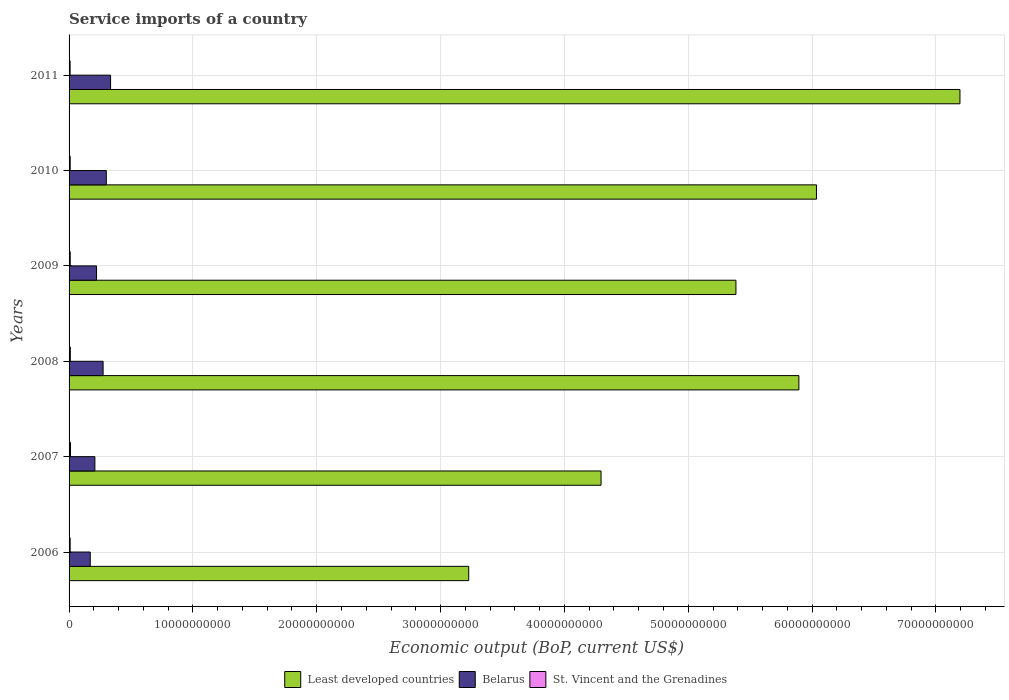How many different coloured bars are there?
Offer a very short reply. 3. How many groups of bars are there?
Give a very brief answer. 6. Are the number of bars on each tick of the Y-axis equal?
Give a very brief answer. Yes. How many bars are there on the 4th tick from the top?
Your answer should be compact. 3. How many bars are there on the 5th tick from the bottom?
Give a very brief answer. 3. What is the label of the 1st group of bars from the top?
Make the answer very short. 2011. What is the service imports in St. Vincent and the Grenadines in 2008?
Offer a very short reply. 1.02e+08. Across all years, what is the maximum service imports in Belarus?
Ensure brevity in your answer.  3.35e+09. Across all years, what is the minimum service imports in St. Vincent and the Grenadines?
Provide a succinct answer. 8.43e+07. In which year was the service imports in St. Vincent and the Grenadines minimum?
Give a very brief answer. 2011. What is the total service imports in St. Vincent and the Grenadines in the graph?
Your answer should be very brief. 5.75e+08. What is the difference between the service imports in Least developed countries in 2009 and that in 2011?
Your response must be concise. -1.81e+1. What is the difference between the service imports in Least developed countries in 2010 and the service imports in St. Vincent and the Grenadines in 2007?
Ensure brevity in your answer.  6.02e+1. What is the average service imports in Least developed countries per year?
Provide a succinct answer. 5.34e+1. In the year 2006, what is the difference between the service imports in St. Vincent and the Grenadines and service imports in Least developed countries?
Ensure brevity in your answer.  -3.22e+1. In how many years, is the service imports in Least developed countries greater than 50000000000 US$?
Provide a short and direct response. 4. What is the ratio of the service imports in St. Vincent and the Grenadines in 2006 to that in 2010?
Provide a succinct answer. 0.96. Is the service imports in Least developed countries in 2009 less than that in 2010?
Give a very brief answer. Yes. What is the difference between the highest and the second highest service imports in St. Vincent and the Grenadines?
Provide a succinct answer. 1.21e+07. What is the difference between the highest and the lowest service imports in St. Vincent and the Grenadines?
Give a very brief answer. 2.99e+07. In how many years, is the service imports in Belarus greater than the average service imports in Belarus taken over all years?
Your response must be concise. 3. What does the 3rd bar from the top in 2008 represents?
Offer a very short reply. Least developed countries. What does the 1st bar from the bottom in 2011 represents?
Make the answer very short. Least developed countries. How many bars are there?
Offer a terse response. 18. What is the difference between two consecutive major ticks on the X-axis?
Offer a very short reply. 1.00e+1. Are the values on the major ticks of X-axis written in scientific E-notation?
Your answer should be very brief. No. Does the graph contain any zero values?
Provide a succinct answer. No. Does the graph contain grids?
Offer a terse response. Yes. Where does the legend appear in the graph?
Offer a very short reply. Bottom center. How many legend labels are there?
Make the answer very short. 3. What is the title of the graph?
Provide a succinct answer. Service imports of a country. What is the label or title of the X-axis?
Make the answer very short. Economic output (BoP, current US$). What is the Economic output (BoP, current US$) of Least developed countries in 2006?
Offer a very short reply. 3.23e+1. What is the Economic output (BoP, current US$) in Belarus in 2006?
Make the answer very short. 1.71e+09. What is the Economic output (BoP, current US$) in St. Vincent and the Grenadines in 2006?
Your answer should be very brief. 8.82e+07. What is the Economic output (BoP, current US$) of Least developed countries in 2007?
Your response must be concise. 4.30e+1. What is the Economic output (BoP, current US$) of Belarus in 2007?
Your response must be concise. 2.08e+09. What is the Economic output (BoP, current US$) in St. Vincent and the Grenadines in 2007?
Make the answer very short. 1.14e+08. What is the Economic output (BoP, current US$) in Least developed countries in 2008?
Offer a very short reply. 5.89e+1. What is the Economic output (BoP, current US$) of Belarus in 2008?
Offer a very short reply. 2.75e+09. What is the Economic output (BoP, current US$) in St. Vincent and the Grenadines in 2008?
Keep it short and to the point. 1.02e+08. What is the Economic output (BoP, current US$) in Least developed countries in 2009?
Give a very brief answer. 5.39e+1. What is the Economic output (BoP, current US$) in Belarus in 2009?
Ensure brevity in your answer.  2.22e+09. What is the Economic output (BoP, current US$) of St. Vincent and the Grenadines in 2009?
Your answer should be very brief. 9.42e+07. What is the Economic output (BoP, current US$) of Least developed countries in 2010?
Offer a very short reply. 6.04e+1. What is the Economic output (BoP, current US$) of Belarus in 2010?
Your answer should be very brief. 3.01e+09. What is the Economic output (BoP, current US$) of St. Vincent and the Grenadines in 2010?
Offer a terse response. 9.15e+07. What is the Economic output (BoP, current US$) in Least developed countries in 2011?
Ensure brevity in your answer.  7.19e+1. What is the Economic output (BoP, current US$) of Belarus in 2011?
Provide a succinct answer. 3.35e+09. What is the Economic output (BoP, current US$) of St. Vincent and the Grenadines in 2011?
Offer a very short reply. 8.43e+07. Across all years, what is the maximum Economic output (BoP, current US$) of Least developed countries?
Your answer should be compact. 7.19e+1. Across all years, what is the maximum Economic output (BoP, current US$) in Belarus?
Your response must be concise. 3.35e+09. Across all years, what is the maximum Economic output (BoP, current US$) of St. Vincent and the Grenadines?
Make the answer very short. 1.14e+08. Across all years, what is the minimum Economic output (BoP, current US$) in Least developed countries?
Offer a very short reply. 3.23e+1. Across all years, what is the minimum Economic output (BoP, current US$) of Belarus?
Provide a short and direct response. 1.71e+09. Across all years, what is the minimum Economic output (BoP, current US$) in St. Vincent and the Grenadines?
Your response must be concise. 8.43e+07. What is the total Economic output (BoP, current US$) of Least developed countries in the graph?
Your answer should be compact. 3.20e+11. What is the total Economic output (BoP, current US$) in Belarus in the graph?
Ensure brevity in your answer.  1.51e+1. What is the total Economic output (BoP, current US$) of St. Vincent and the Grenadines in the graph?
Ensure brevity in your answer.  5.75e+08. What is the difference between the Economic output (BoP, current US$) in Least developed countries in 2006 and that in 2007?
Give a very brief answer. -1.07e+1. What is the difference between the Economic output (BoP, current US$) of Belarus in 2006 and that in 2007?
Provide a short and direct response. -3.74e+08. What is the difference between the Economic output (BoP, current US$) in St. Vincent and the Grenadines in 2006 and that in 2007?
Keep it short and to the point. -2.60e+07. What is the difference between the Economic output (BoP, current US$) in Least developed countries in 2006 and that in 2008?
Ensure brevity in your answer.  -2.67e+1. What is the difference between the Economic output (BoP, current US$) in Belarus in 2006 and that in 2008?
Your answer should be very brief. -1.04e+09. What is the difference between the Economic output (BoP, current US$) of St. Vincent and the Grenadines in 2006 and that in 2008?
Your response must be concise. -1.40e+07. What is the difference between the Economic output (BoP, current US$) in Least developed countries in 2006 and that in 2009?
Your response must be concise. -2.16e+1. What is the difference between the Economic output (BoP, current US$) in Belarus in 2006 and that in 2009?
Your response must be concise. -5.07e+08. What is the difference between the Economic output (BoP, current US$) of St. Vincent and the Grenadines in 2006 and that in 2009?
Provide a short and direct response. -6.06e+06. What is the difference between the Economic output (BoP, current US$) in Least developed countries in 2006 and that in 2010?
Give a very brief answer. -2.81e+1. What is the difference between the Economic output (BoP, current US$) in Belarus in 2006 and that in 2010?
Provide a short and direct response. -1.30e+09. What is the difference between the Economic output (BoP, current US$) in St. Vincent and the Grenadines in 2006 and that in 2010?
Provide a short and direct response. -3.29e+06. What is the difference between the Economic output (BoP, current US$) of Least developed countries in 2006 and that in 2011?
Offer a terse response. -3.97e+1. What is the difference between the Economic output (BoP, current US$) of Belarus in 2006 and that in 2011?
Offer a terse response. -1.64e+09. What is the difference between the Economic output (BoP, current US$) of St. Vincent and the Grenadines in 2006 and that in 2011?
Provide a succinct answer. 3.84e+06. What is the difference between the Economic output (BoP, current US$) of Least developed countries in 2007 and that in 2008?
Give a very brief answer. -1.60e+1. What is the difference between the Economic output (BoP, current US$) in Belarus in 2007 and that in 2008?
Your response must be concise. -6.63e+08. What is the difference between the Economic output (BoP, current US$) in St. Vincent and the Grenadines in 2007 and that in 2008?
Ensure brevity in your answer.  1.21e+07. What is the difference between the Economic output (BoP, current US$) in Least developed countries in 2007 and that in 2009?
Provide a short and direct response. -1.09e+1. What is the difference between the Economic output (BoP, current US$) in Belarus in 2007 and that in 2009?
Offer a terse response. -1.33e+08. What is the difference between the Economic output (BoP, current US$) in St. Vincent and the Grenadines in 2007 and that in 2009?
Offer a terse response. 2.00e+07. What is the difference between the Economic output (BoP, current US$) in Least developed countries in 2007 and that in 2010?
Your response must be concise. -1.74e+1. What is the difference between the Economic output (BoP, current US$) in Belarus in 2007 and that in 2010?
Provide a short and direct response. -9.22e+08. What is the difference between the Economic output (BoP, current US$) in St. Vincent and the Grenadines in 2007 and that in 2010?
Keep it short and to the point. 2.27e+07. What is the difference between the Economic output (BoP, current US$) of Least developed countries in 2007 and that in 2011?
Keep it short and to the point. -2.90e+1. What is the difference between the Economic output (BoP, current US$) of Belarus in 2007 and that in 2011?
Your response must be concise. -1.27e+09. What is the difference between the Economic output (BoP, current US$) of St. Vincent and the Grenadines in 2007 and that in 2011?
Make the answer very short. 2.99e+07. What is the difference between the Economic output (BoP, current US$) of Least developed countries in 2008 and that in 2009?
Provide a succinct answer. 5.08e+09. What is the difference between the Economic output (BoP, current US$) of Belarus in 2008 and that in 2009?
Provide a short and direct response. 5.30e+08. What is the difference between the Economic output (BoP, current US$) in St. Vincent and the Grenadines in 2008 and that in 2009?
Keep it short and to the point. 7.90e+06. What is the difference between the Economic output (BoP, current US$) in Least developed countries in 2008 and that in 2010?
Give a very brief answer. -1.42e+09. What is the difference between the Economic output (BoP, current US$) in Belarus in 2008 and that in 2010?
Your answer should be very brief. -2.59e+08. What is the difference between the Economic output (BoP, current US$) of St. Vincent and the Grenadines in 2008 and that in 2010?
Your answer should be compact. 1.07e+07. What is the difference between the Economic output (BoP, current US$) in Least developed countries in 2008 and that in 2011?
Your answer should be very brief. -1.30e+1. What is the difference between the Economic output (BoP, current US$) of Belarus in 2008 and that in 2011?
Offer a terse response. -6.04e+08. What is the difference between the Economic output (BoP, current US$) of St. Vincent and the Grenadines in 2008 and that in 2011?
Keep it short and to the point. 1.78e+07. What is the difference between the Economic output (BoP, current US$) in Least developed countries in 2009 and that in 2010?
Make the answer very short. -6.50e+09. What is the difference between the Economic output (BoP, current US$) of Belarus in 2009 and that in 2010?
Your answer should be compact. -7.89e+08. What is the difference between the Economic output (BoP, current US$) in St. Vincent and the Grenadines in 2009 and that in 2010?
Your answer should be very brief. 2.78e+06. What is the difference between the Economic output (BoP, current US$) in Least developed countries in 2009 and that in 2011?
Offer a terse response. -1.81e+1. What is the difference between the Economic output (BoP, current US$) in Belarus in 2009 and that in 2011?
Keep it short and to the point. -1.13e+09. What is the difference between the Economic output (BoP, current US$) of St. Vincent and the Grenadines in 2009 and that in 2011?
Provide a short and direct response. 9.90e+06. What is the difference between the Economic output (BoP, current US$) in Least developed countries in 2010 and that in 2011?
Ensure brevity in your answer.  -1.16e+1. What is the difference between the Economic output (BoP, current US$) in Belarus in 2010 and that in 2011?
Offer a very short reply. -3.45e+08. What is the difference between the Economic output (BoP, current US$) of St. Vincent and the Grenadines in 2010 and that in 2011?
Ensure brevity in your answer.  7.13e+06. What is the difference between the Economic output (BoP, current US$) of Least developed countries in 2006 and the Economic output (BoP, current US$) of Belarus in 2007?
Offer a terse response. 3.02e+1. What is the difference between the Economic output (BoP, current US$) of Least developed countries in 2006 and the Economic output (BoP, current US$) of St. Vincent and the Grenadines in 2007?
Provide a succinct answer. 3.22e+1. What is the difference between the Economic output (BoP, current US$) of Belarus in 2006 and the Economic output (BoP, current US$) of St. Vincent and the Grenadines in 2007?
Offer a very short reply. 1.60e+09. What is the difference between the Economic output (BoP, current US$) in Least developed countries in 2006 and the Economic output (BoP, current US$) in Belarus in 2008?
Keep it short and to the point. 2.95e+1. What is the difference between the Economic output (BoP, current US$) of Least developed countries in 2006 and the Economic output (BoP, current US$) of St. Vincent and the Grenadines in 2008?
Give a very brief answer. 3.22e+1. What is the difference between the Economic output (BoP, current US$) of Belarus in 2006 and the Economic output (BoP, current US$) of St. Vincent and the Grenadines in 2008?
Provide a succinct answer. 1.61e+09. What is the difference between the Economic output (BoP, current US$) in Least developed countries in 2006 and the Economic output (BoP, current US$) in Belarus in 2009?
Offer a terse response. 3.01e+1. What is the difference between the Economic output (BoP, current US$) of Least developed countries in 2006 and the Economic output (BoP, current US$) of St. Vincent and the Grenadines in 2009?
Your answer should be very brief. 3.22e+1. What is the difference between the Economic output (BoP, current US$) of Belarus in 2006 and the Economic output (BoP, current US$) of St. Vincent and the Grenadines in 2009?
Offer a terse response. 1.62e+09. What is the difference between the Economic output (BoP, current US$) in Least developed countries in 2006 and the Economic output (BoP, current US$) in Belarus in 2010?
Make the answer very short. 2.93e+1. What is the difference between the Economic output (BoP, current US$) of Least developed countries in 2006 and the Economic output (BoP, current US$) of St. Vincent and the Grenadines in 2010?
Ensure brevity in your answer.  3.22e+1. What is the difference between the Economic output (BoP, current US$) in Belarus in 2006 and the Economic output (BoP, current US$) in St. Vincent and the Grenadines in 2010?
Your answer should be very brief. 1.62e+09. What is the difference between the Economic output (BoP, current US$) of Least developed countries in 2006 and the Economic output (BoP, current US$) of Belarus in 2011?
Your response must be concise. 2.89e+1. What is the difference between the Economic output (BoP, current US$) of Least developed countries in 2006 and the Economic output (BoP, current US$) of St. Vincent and the Grenadines in 2011?
Provide a short and direct response. 3.22e+1. What is the difference between the Economic output (BoP, current US$) in Belarus in 2006 and the Economic output (BoP, current US$) in St. Vincent and the Grenadines in 2011?
Offer a terse response. 1.63e+09. What is the difference between the Economic output (BoP, current US$) of Least developed countries in 2007 and the Economic output (BoP, current US$) of Belarus in 2008?
Your answer should be very brief. 4.02e+1. What is the difference between the Economic output (BoP, current US$) of Least developed countries in 2007 and the Economic output (BoP, current US$) of St. Vincent and the Grenadines in 2008?
Provide a succinct answer. 4.29e+1. What is the difference between the Economic output (BoP, current US$) in Belarus in 2007 and the Economic output (BoP, current US$) in St. Vincent and the Grenadines in 2008?
Your answer should be very brief. 1.98e+09. What is the difference between the Economic output (BoP, current US$) of Least developed countries in 2007 and the Economic output (BoP, current US$) of Belarus in 2009?
Provide a short and direct response. 4.07e+1. What is the difference between the Economic output (BoP, current US$) of Least developed countries in 2007 and the Economic output (BoP, current US$) of St. Vincent and the Grenadines in 2009?
Offer a very short reply. 4.29e+1. What is the difference between the Economic output (BoP, current US$) of Belarus in 2007 and the Economic output (BoP, current US$) of St. Vincent and the Grenadines in 2009?
Offer a very short reply. 1.99e+09. What is the difference between the Economic output (BoP, current US$) of Least developed countries in 2007 and the Economic output (BoP, current US$) of Belarus in 2010?
Your answer should be very brief. 4.00e+1. What is the difference between the Economic output (BoP, current US$) in Least developed countries in 2007 and the Economic output (BoP, current US$) in St. Vincent and the Grenadines in 2010?
Make the answer very short. 4.29e+1. What is the difference between the Economic output (BoP, current US$) in Belarus in 2007 and the Economic output (BoP, current US$) in St. Vincent and the Grenadines in 2010?
Make the answer very short. 1.99e+09. What is the difference between the Economic output (BoP, current US$) in Least developed countries in 2007 and the Economic output (BoP, current US$) in Belarus in 2011?
Your answer should be compact. 3.96e+1. What is the difference between the Economic output (BoP, current US$) in Least developed countries in 2007 and the Economic output (BoP, current US$) in St. Vincent and the Grenadines in 2011?
Offer a very short reply. 4.29e+1. What is the difference between the Economic output (BoP, current US$) of Belarus in 2007 and the Economic output (BoP, current US$) of St. Vincent and the Grenadines in 2011?
Offer a terse response. 2.00e+09. What is the difference between the Economic output (BoP, current US$) in Least developed countries in 2008 and the Economic output (BoP, current US$) in Belarus in 2009?
Give a very brief answer. 5.67e+1. What is the difference between the Economic output (BoP, current US$) of Least developed countries in 2008 and the Economic output (BoP, current US$) of St. Vincent and the Grenadines in 2009?
Ensure brevity in your answer.  5.88e+1. What is the difference between the Economic output (BoP, current US$) in Belarus in 2008 and the Economic output (BoP, current US$) in St. Vincent and the Grenadines in 2009?
Provide a short and direct response. 2.65e+09. What is the difference between the Economic output (BoP, current US$) of Least developed countries in 2008 and the Economic output (BoP, current US$) of Belarus in 2010?
Keep it short and to the point. 5.59e+1. What is the difference between the Economic output (BoP, current US$) in Least developed countries in 2008 and the Economic output (BoP, current US$) in St. Vincent and the Grenadines in 2010?
Offer a terse response. 5.88e+1. What is the difference between the Economic output (BoP, current US$) of Belarus in 2008 and the Economic output (BoP, current US$) of St. Vincent and the Grenadines in 2010?
Keep it short and to the point. 2.66e+09. What is the difference between the Economic output (BoP, current US$) of Least developed countries in 2008 and the Economic output (BoP, current US$) of Belarus in 2011?
Your response must be concise. 5.56e+1. What is the difference between the Economic output (BoP, current US$) in Least developed countries in 2008 and the Economic output (BoP, current US$) in St. Vincent and the Grenadines in 2011?
Your answer should be compact. 5.89e+1. What is the difference between the Economic output (BoP, current US$) of Belarus in 2008 and the Economic output (BoP, current US$) of St. Vincent and the Grenadines in 2011?
Give a very brief answer. 2.66e+09. What is the difference between the Economic output (BoP, current US$) of Least developed countries in 2009 and the Economic output (BoP, current US$) of Belarus in 2010?
Your answer should be very brief. 5.08e+1. What is the difference between the Economic output (BoP, current US$) of Least developed countries in 2009 and the Economic output (BoP, current US$) of St. Vincent and the Grenadines in 2010?
Your answer should be compact. 5.38e+1. What is the difference between the Economic output (BoP, current US$) of Belarus in 2009 and the Economic output (BoP, current US$) of St. Vincent and the Grenadines in 2010?
Ensure brevity in your answer.  2.13e+09. What is the difference between the Economic output (BoP, current US$) in Least developed countries in 2009 and the Economic output (BoP, current US$) in Belarus in 2011?
Your answer should be compact. 5.05e+1. What is the difference between the Economic output (BoP, current US$) in Least developed countries in 2009 and the Economic output (BoP, current US$) in St. Vincent and the Grenadines in 2011?
Make the answer very short. 5.38e+1. What is the difference between the Economic output (BoP, current US$) of Belarus in 2009 and the Economic output (BoP, current US$) of St. Vincent and the Grenadines in 2011?
Ensure brevity in your answer.  2.13e+09. What is the difference between the Economic output (BoP, current US$) of Least developed countries in 2010 and the Economic output (BoP, current US$) of Belarus in 2011?
Ensure brevity in your answer.  5.70e+1. What is the difference between the Economic output (BoP, current US$) in Least developed countries in 2010 and the Economic output (BoP, current US$) in St. Vincent and the Grenadines in 2011?
Provide a succinct answer. 6.03e+1. What is the difference between the Economic output (BoP, current US$) of Belarus in 2010 and the Economic output (BoP, current US$) of St. Vincent and the Grenadines in 2011?
Your response must be concise. 2.92e+09. What is the average Economic output (BoP, current US$) of Least developed countries per year?
Ensure brevity in your answer.  5.34e+1. What is the average Economic output (BoP, current US$) in Belarus per year?
Offer a very short reply. 2.52e+09. What is the average Economic output (BoP, current US$) of St. Vincent and the Grenadines per year?
Offer a terse response. 9.58e+07. In the year 2006, what is the difference between the Economic output (BoP, current US$) in Least developed countries and Economic output (BoP, current US$) in Belarus?
Offer a terse response. 3.06e+1. In the year 2006, what is the difference between the Economic output (BoP, current US$) in Least developed countries and Economic output (BoP, current US$) in St. Vincent and the Grenadines?
Provide a succinct answer. 3.22e+1. In the year 2006, what is the difference between the Economic output (BoP, current US$) of Belarus and Economic output (BoP, current US$) of St. Vincent and the Grenadines?
Your answer should be very brief. 1.62e+09. In the year 2007, what is the difference between the Economic output (BoP, current US$) of Least developed countries and Economic output (BoP, current US$) of Belarus?
Ensure brevity in your answer.  4.09e+1. In the year 2007, what is the difference between the Economic output (BoP, current US$) in Least developed countries and Economic output (BoP, current US$) in St. Vincent and the Grenadines?
Offer a terse response. 4.28e+1. In the year 2007, what is the difference between the Economic output (BoP, current US$) in Belarus and Economic output (BoP, current US$) in St. Vincent and the Grenadines?
Keep it short and to the point. 1.97e+09. In the year 2008, what is the difference between the Economic output (BoP, current US$) of Least developed countries and Economic output (BoP, current US$) of Belarus?
Your answer should be compact. 5.62e+1. In the year 2008, what is the difference between the Economic output (BoP, current US$) in Least developed countries and Economic output (BoP, current US$) in St. Vincent and the Grenadines?
Your answer should be compact. 5.88e+1. In the year 2008, what is the difference between the Economic output (BoP, current US$) in Belarus and Economic output (BoP, current US$) in St. Vincent and the Grenadines?
Provide a succinct answer. 2.65e+09. In the year 2009, what is the difference between the Economic output (BoP, current US$) of Least developed countries and Economic output (BoP, current US$) of Belarus?
Keep it short and to the point. 5.16e+1. In the year 2009, what is the difference between the Economic output (BoP, current US$) in Least developed countries and Economic output (BoP, current US$) in St. Vincent and the Grenadines?
Offer a terse response. 5.38e+1. In the year 2009, what is the difference between the Economic output (BoP, current US$) of Belarus and Economic output (BoP, current US$) of St. Vincent and the Grenadines?
Your answer should be very brief. 2.12e+09. In the year 2010, what is the difference between the Economic output (BoP, current US$) in Least developed countries and Economic output (BoP, current US$) in Belarus?
Offer a very short reply. 5.73e+1. In the year 2010, what is the difference between the Economic output (BoP, current US$) of Least developed countries and Economic output (BoP, current US$) of St. Vincent and the Grenadines?
Offer a very short reply. 6.03e+1. In the year 2010, what is the difference between the Economic output (BoP, current US$) of Belarus and Economic output (BoP, current US$) of St. Vincent and the Grenadines?
Your answer should be compact. 2.92e+09. In the year 2011, what is the difference between the Economic output (BoP, current US$) in Least developed countries and Economic output (BoP, current US$) in Belarus?
Offer a terse response. 6.86e+1. In the year 2011, what is the difference between the Economic output (BoP, current US$) of Least developed countries and Economic output (BoP, current US$) of St. Vincent and the Grenadines?
Provide a succinct answer. 7.19e+1. In the year 2011, what is the difference between the Economic output (BoP, current US$) of Belarus and Economic output (BoP, current US$) of St. Vincent and the Grenadines?
Give a very brief answer. 3.27e+09. What is the ratio of the Economic output (BoP, current US$) of Least developed countries in 2006 to that in 2007?
Your response must be concise. 0.75. What is the ratio of the Economic output (BoP, current US$) in Belarus in 2006 to that in 2007?
Offer a very short reply. 0.82. What is the ratio of the Economic output (BoP, current US$) of St. Vincent and the Grenadines in 2006 to that in 2007?
Ensure brevity in your answer.  0.77. What is the ratio of the Economic output (BoP, current US$) in Least developed countries in 2006 to that in 2008?
Keep it short and to the point. 0.55. What is the ratio of the Economic output (BoP, current US$) of Belarus in 2006 to that in 2008?
Provide a short and direct response. 0.62. What is the ratio of the Economic output (BoP, current US$) of St. Vincent and the Grenadines in 2006 to that in 2008?
Provide a short and direct response. 0.86. What is the ratio of the Economic output (BoP, current US$) in Least developed countries in 2006 to that in 2009?
Make the answer very short. 0.6. What is the ratio of the Economic output (BoP, current US$) in Belarus in 2006 to that in 2009?
Give a very brief answer. 0.77. What is the ratio of the Economic output (BoP, current US$) in St. Vincent and the Grenadines in 2006 to that in 2009?
Your response must be concise. 0.94. What is the ratio of the Economic output (BoP, current US$) in Least developed countries in 2006 to that in 2010?
Provide a short and direct response. 0.53. What is the ratio of the Economic output (BoP, current US$) in Belarus in 2006 to that in 2010?
Make the answer very short. 0.57. What is the ratio of the Economic output (BoP, current US$) in Least developed countries in 2006 to that in 2011?
Your response must be concise. 0.45. What is the ratio of the Economic output (BoP, current US$) of Belarus in 2006 to that in 2011?
Make the answer very short. 0.51. What is the ratio of the Economic output (BoP, current US$) in St. Vincent and the Grenadines in 2006 to that in 2011?
Provide a short and direct response. 1.05. What is the ratio of the Economic output (BoP, current US$) of Least developed countries in 2007 to that in 2008?
Keep it short and to the point. 0.73. What is the ratio of the Economic output (BoP, current US$) in Belarus in 2007 to that in 2008?
Offer a terse response. 0.76. What is the ratio of the Economic output (BoP, current US$) of St. Vincent and the Grenadines in 2007 to that in 2008?
Keep it short and to the point. 1.12. What is the ratio of the Economic output (BoP, current US$) in Least developed countries in 2007 to that in 2009?
Provide a succinct answer. 0.8. What is the ratio of the Economic output (BoP, current US$) in Belarus in 2007 to that in 2009?
Provide a succinct answer. 0.94. What is the ratio of the Economic output (BoP, current US$) in St. Vincent and the Grenadines in 2007 to that in 2009?
Offer a terse response. 1.21. What is the ratio of the Economic output (BoP, current US$) of Least developed countries in 2007 to that in 2010?
Your response must be concise. 0.71. What is the ratio of the Economic output (BoP, current US$) of Belarus in 2007 to that in 2010?
Ensure brevity in your answer.  0.69. What is the ratio of the Economic output (BoP, current US$) of St. Vincent and the Grenadines in 2007 to that in 2010?
Offer a terse response. 1.25. What is the ratio of the Economic output (BoP, current US$) in Least developed countries in 2007 to that in 2011?
Provide a succinct answer. 0.6. What is the ratio of the Economic output (BoP, current US$) in Belarus in 2007 to that in 2011?
Provide a short and direct response. 0.62. What is the ratio of the Economic output (BoP, current US$) of St. Vincent and the Grenadines in 2007 to that in 2011?
Offer a terse response. 1.35. What is the ratio of the Economic output (BoP, current US$) of Least developed countries in 2008 to that in 2009?
Your response must be concise. 1.09. What is the ratio of the Economic output (BoP, current US$) in Belarus in 2008 to that in 2009?
Provide a succinct answer. 1.24. What is the ratio of the Economic output (BoP, current US$) in St. Vincent and the Grenadines in 2008 to that in 2009?
Your response must be concise. 1.08. What is the ratio of the Economic output (BoP, current US$) in Least developed countries in 2008 to that in 2010?
Your answer should be very brief. 0.98. What is the ratio of the Economic output (BoP, current US$) in Belarus in 2008 to that in 2010?
Your answer should be very brief. 0.91. What is the ratio of the Economic output (BoP, current US$) of St. Vincent and the Grenadines in 2008 to that in 2010?
Your answer should be compact. 1.12. What is the ratio of the Economic output (BoP, current US$) in Least developed countries in 2008 to that in 2011?
Ensure brevity in your answer.  0.82. What is the ratio of the Economic output (BoP, current US$) of Belarus in 2008 to that in 2011?
Your response must be concise. 0.82. What is the ratio of the Economic output (BoP, current US$) of St. Vincent and the Grenadines in 2008 to that in 2011?
Give a very brief answer. 1.21. What is the ratio of the Economic output (BoP, current US$) of Least developed countries in 2009 to that in 2010?
Provide a succinct answer. 0.89. What is the ratio of the Economic output (BoP, current US$) of Belarus in 2009 to that in 2010?
Your answer should be very brief. 0.74. What is the ratio of the Economic output (BoP, current US$) of St. Vincent and the Grenadines in 2009 to that in 2010?
Keep it short and to the point. 1.03. What is the ratio of the Economic output (BoP, current US$) in Least developed countries in 2009 to that in 2011?
Offer a very short reply. 0.75. What is the ratio of the Economic output (BoP, current US$) in Belarus in 2009 to that in 2011?
Offer a very short reply. 0.66. What is the ratio of the Economic output (BoP, current US$) of St. Vincent and the Grenadines in 2009 to that in 2011?
Offer a terse response. 1.12. What is the ratio of the Economic output (BoP, current US$) of Least developed countries in 2010 to that in 2011?
Your answer should be very brief. 0.84. What is the ratio of the Economic output (BoP, current US$) in Belarus in 2010 to that in 2011?
Provide a succinct answer. 0.9. What is the ratio of the Economic output (BoP, current US$) of St. Vincent and the Grenadines in 2010 to that in 2011?
Make the answer very short. 1.08. What is the difference between the highest and the second highest Economic output (BoP, current US$) of Least developed countries?
Give a very brief answer. 1.16e+1. What is the difference between the highest and the second highest Economic output (BoP, current US$) in Belarus?
Offer a terse response. 3.45e+08. What is the difference between the highest and the second highest Economic output (BoP, current US$) of St. Vincent and the Grenadines?
Your answer should be very brief. 1.21e+07. What is the difference between the highest and the lowest Economic output (BoP, current US$) of Least developed countries?
Provide a succinct answer. 3.97e+1. What is the difference between the highest and the lowest Economic output (BoP, current US$) in Belarus?
Make the answer very short. 1.64e+09. What is the difference between the highest and the lowest Economic output (BoP, current US$) of St. Vincent and the Grenadines?
Your answer should be compact. 2.99e+07. 